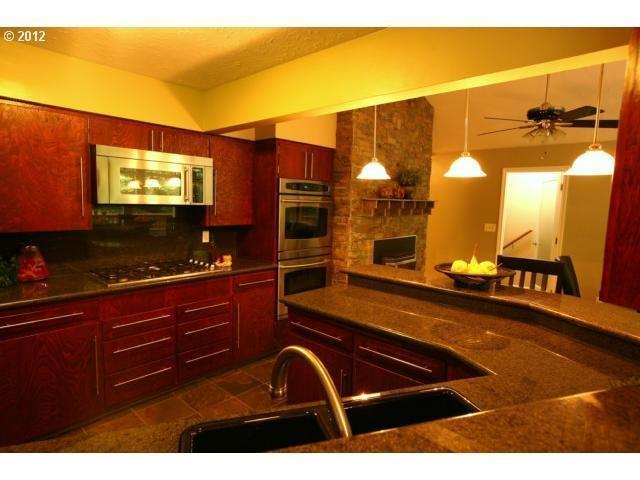How many cows can be seen?
Give a very brief answer. 0. 